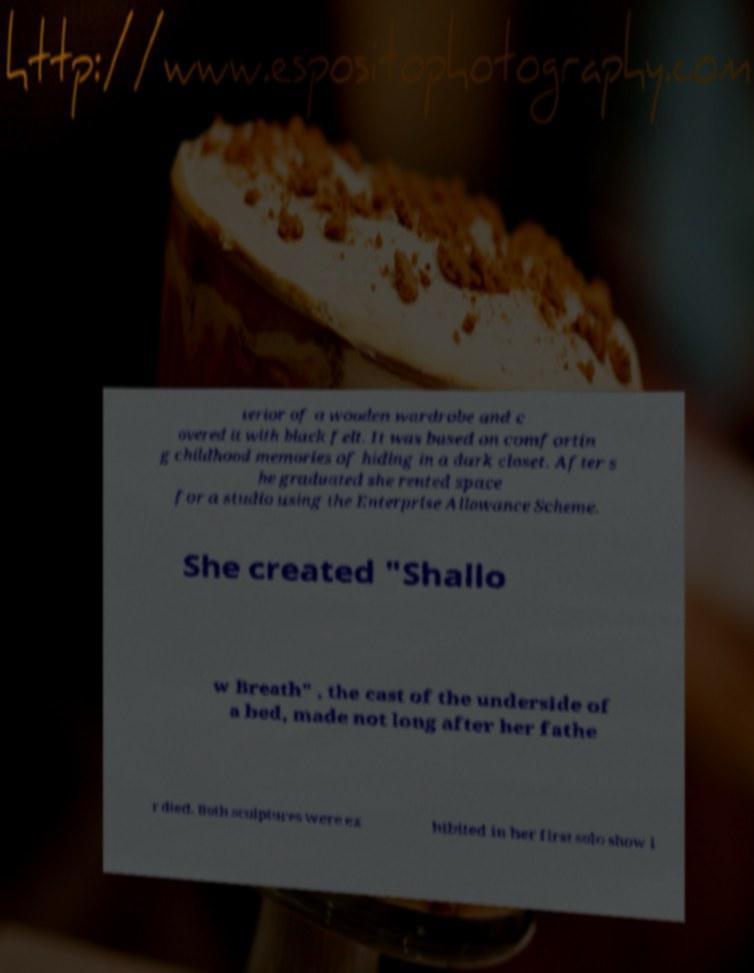What messages or text are displayed in this image? I need them in a readable, typed format. terior of a wooden wardrobe and c overed it with black felt. It was based on comfortin g childhood memories of hiding in a dark closet. After s he graduated she rented space for a studio using the Enterprise Allowance Scheme. She created "Shallo w Breath" , the cast of the underside of a bed, made not long after her fathe r died. Both sculptures were ex hibited in her first solo show i 